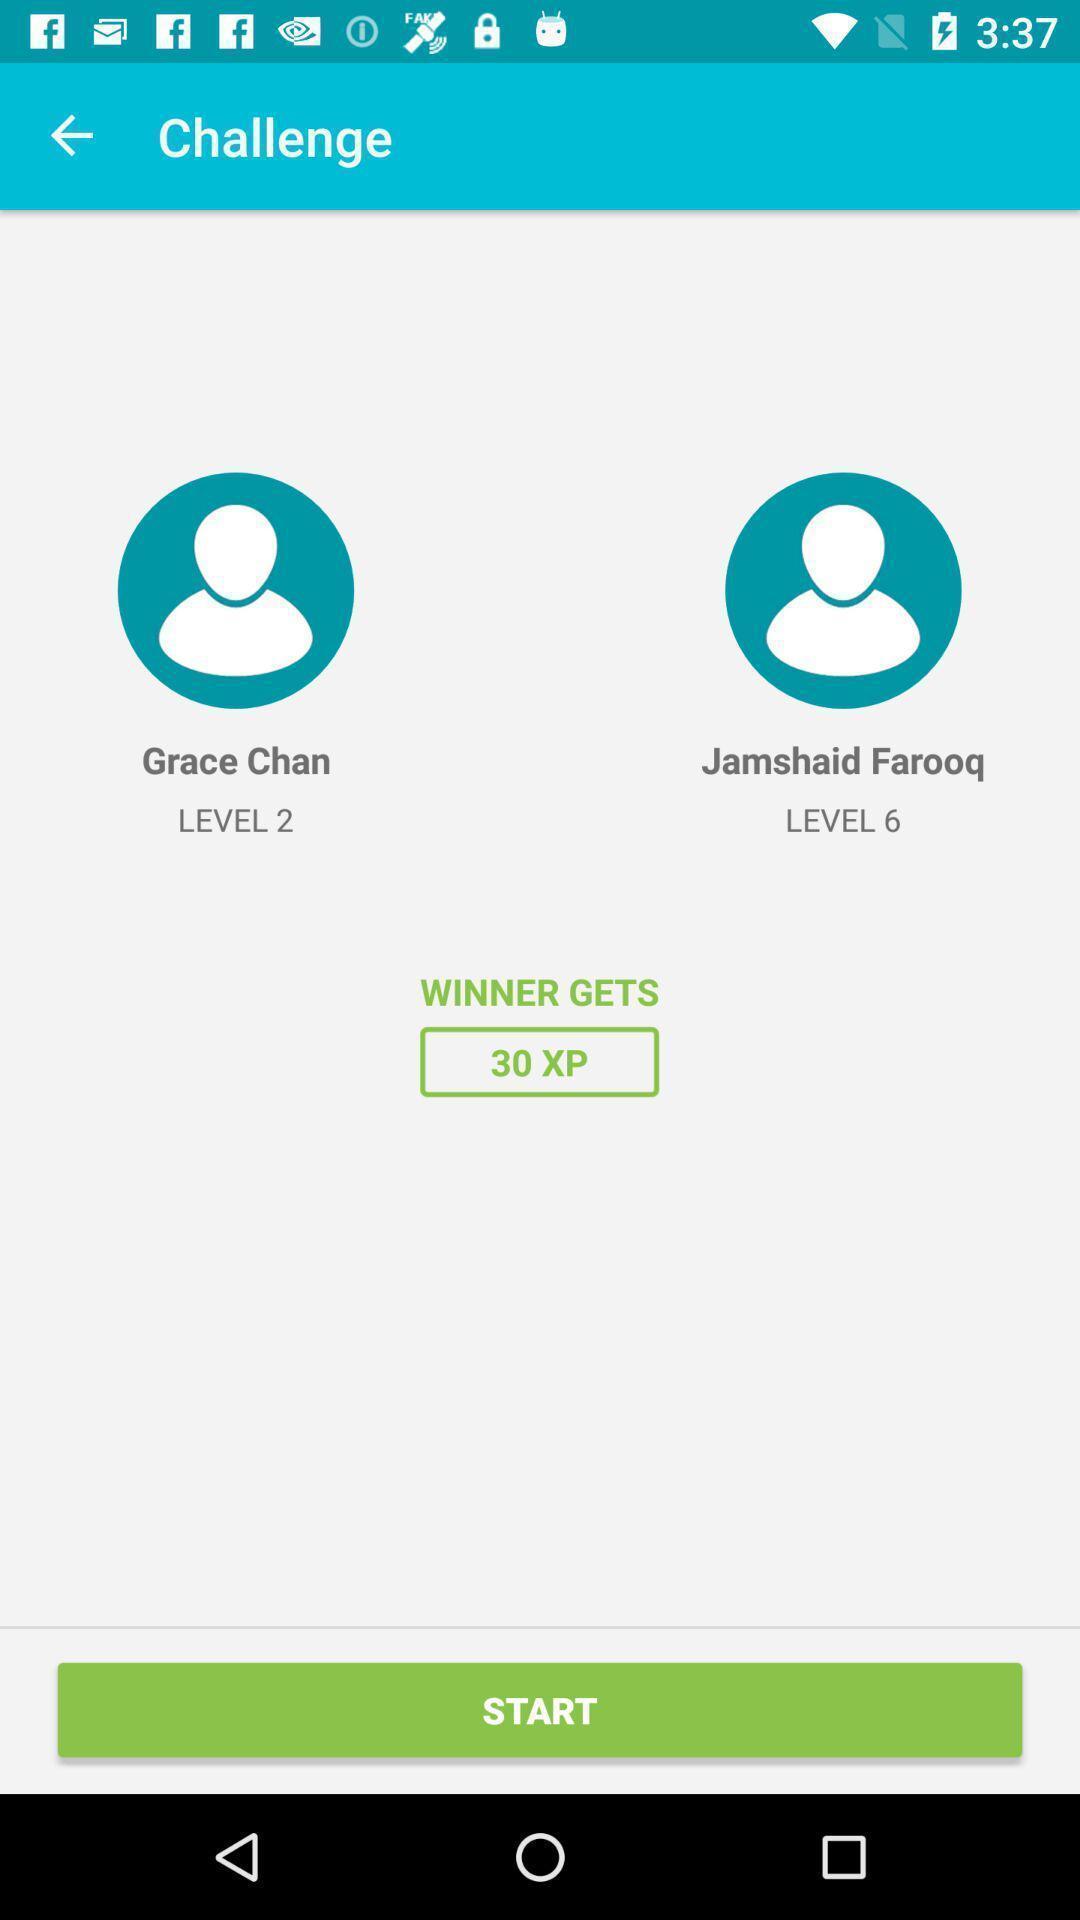Provide a detailed account of this screenshot. Page shows to start the game app. 